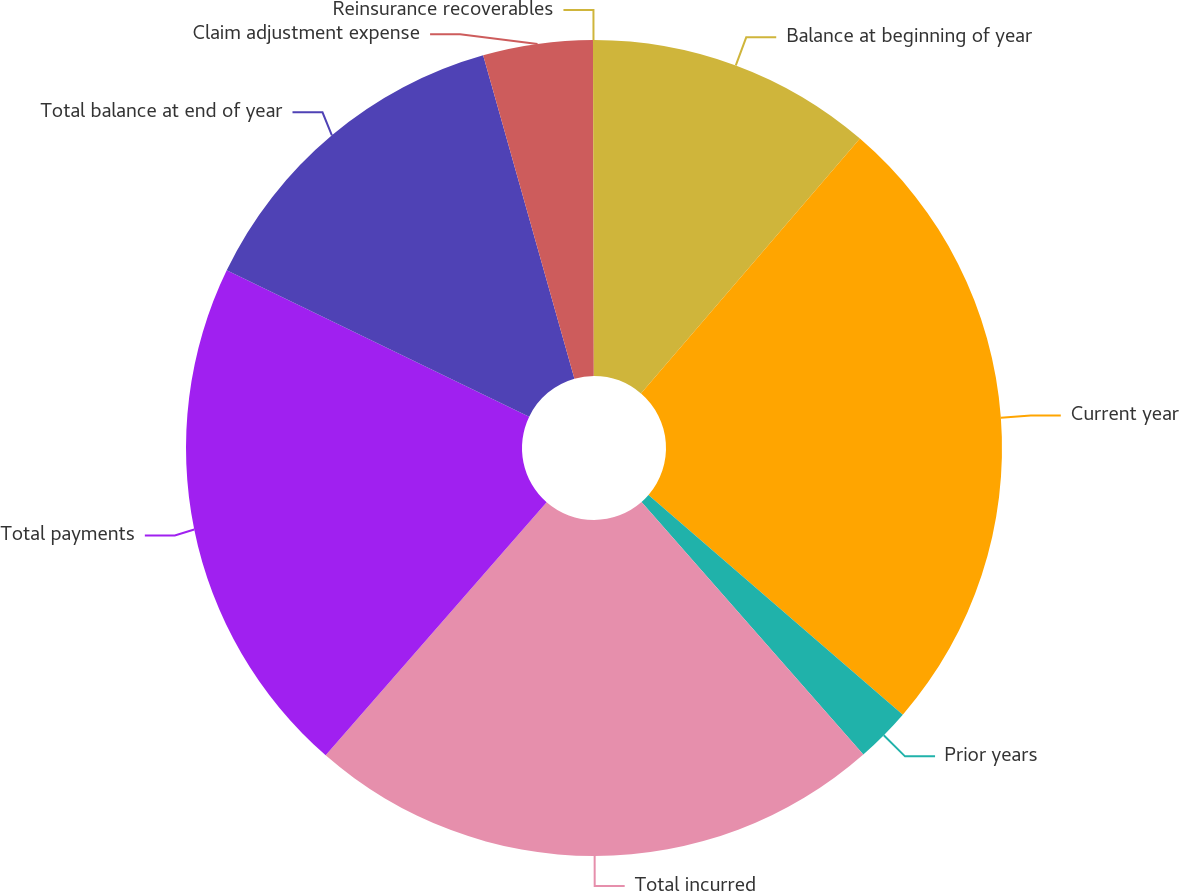<chart> <loc_0><loc_0><loc_500><loc_500><pie_chart><fcel>Balance at beginning of year<fcel>Current year<fcel>Prior years<fcel>Total incurred<fcel>Total payments<fcel>Total balance at end of year<fcel>Claim adjustment expense<fcel>Reinsurance recoverables<nl><fcel>11.3%<fcel>25.04%<fcel>2.19%<fcel>22.9%<fcel>20.75%<fcel>13.45%<fcel>4.34%<fcel>0.04%<nl></chart> 